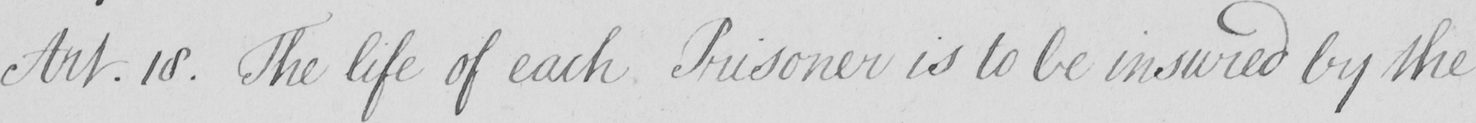Transcribe the text shown in this historical manuscript line. Art.18 . The life of each Prisoner is to be insured by the 